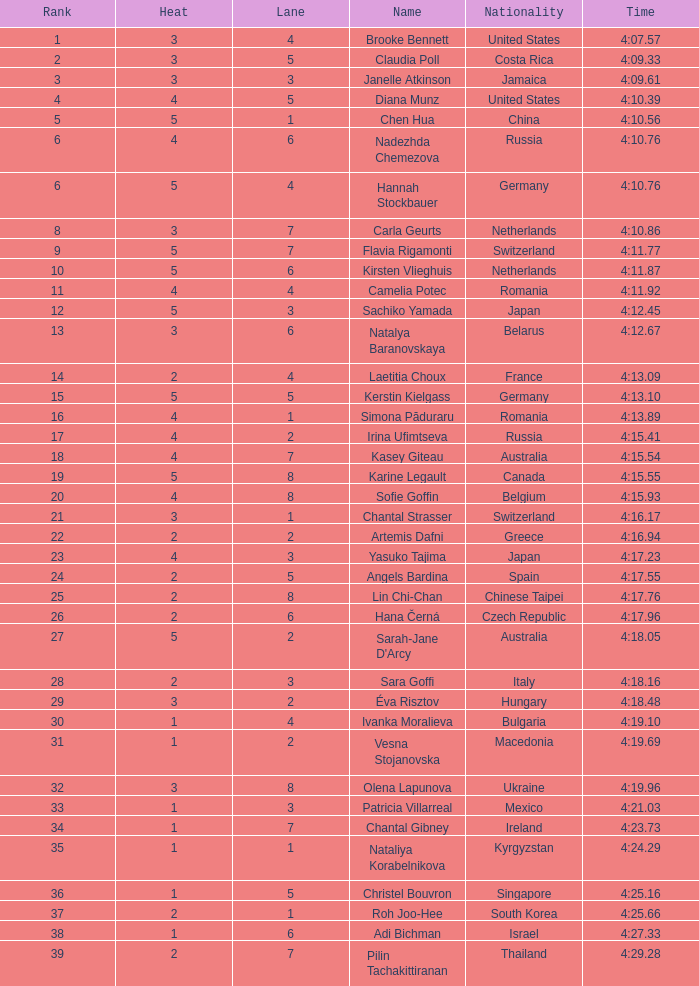Name the average rank with larger than 3 and heat more than 5 None. 